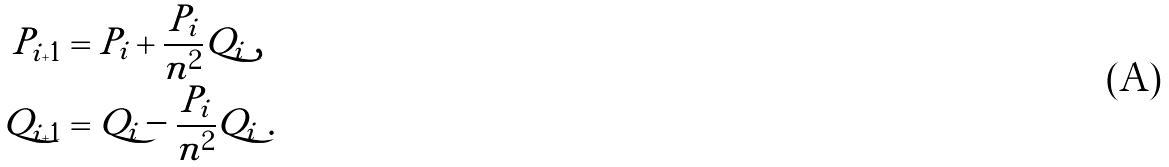<formula> <loc_0><loc_0><loc_500><loc_500>P _ { i + 1 } & = P _ { i } + \frac { P _ { i } } { n ^ { 2 } } Q _ { i } \ , \\ Q _ { i + 1 } & = Q _ { i } - \frac { P _ { i } } { n ^ { 2 } } Q _ { i } \ .</formula> 